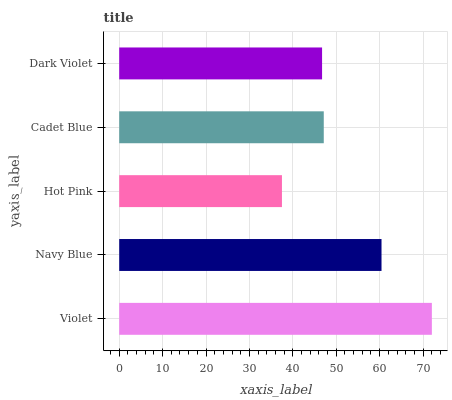Is Hot Pink the minimum?
Answer yes or no. Yes. Is Violet the maximum?
Answer yes or no. Yes. Is Navy Blue the minimum?
Answer yes or no. No. Is Navy Blue the maximum?
Answer yes or no. No. Is Violet greater than Navy Blue?
Answer yes or no. Yes. Is Navy Blue less than Violet?
Answer yes or no. Yes. Is Navy Blue greater than Violet?
Answer yes or no. No. Is Violet less than Navy Blue?
Answer yes or no. No. Is Cadet Blue the high median?
Answer yes or no. Yes. Is Cadet Blue the low median?
Answer yes or no. Yes. Is Dark Violet the high median?
Answer yes or no. No. Is Navy Blue the low median?
Answer yes or no. No. 